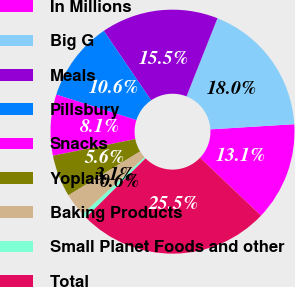Convert chart. <chart><loc_0><loc_0><loc_500><loc_500><pie_chart><fcel>In Millions<fcel>Big G<fcel>Meals<fcel>Pillsbury<fcel>Snacks<fcel>Yoplait<fcel>Baking Products<fcel>Small Planet Foods and other<fcel>Total<nl><fcel>13.05%<fcel>18.02%<fcel>15.53%<fcel>10.56%<fcel>8.07%<fcel>5.58%<fcel>3.09%<fcel>0.6%<fcel>25.49%<nl></chart> 